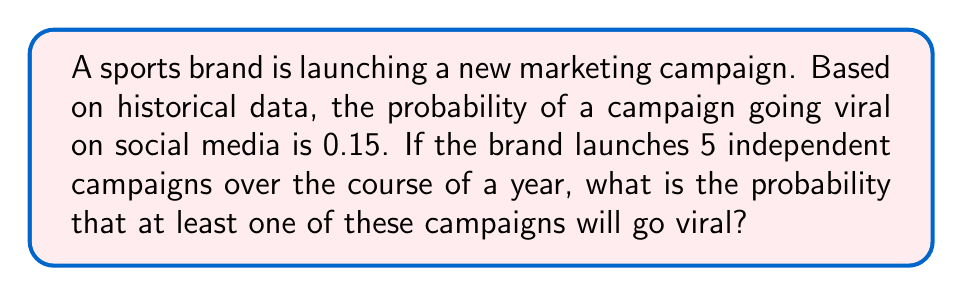Solve this math problem. Let's approach this step-by-step:

1) First, we need to understand what we're calculating. We want the probability of at least one campaign going viral out of 5 campaigns.

2) It's often easier to calculate the probability of the complement event (no campaigns going viral) and then subtract from 1.

3) The probability of a single campaign not going viral is:
   $1 - 0.15 = 0.85$

4) For all 5 campaigns to not go viral, each individual campaign must not go viral. Since the campaigns are independent, we multiply these probabilities:
   $$(0.85)^5$$

5) This gives us the probability that none of the campaigns go viral. To find the probability that at least one goes viral, we subtract this from 1:

   $$1 - (0.85)^5$$

6) Let's calculate this:
   $$1 - (0.85)^5 = 1 - 0.4437 = 0.5563$$

Therefore, the probability that at least one campaign will go viral is approximately 0.5563 or 55.63%.
Answer: 0.5563 